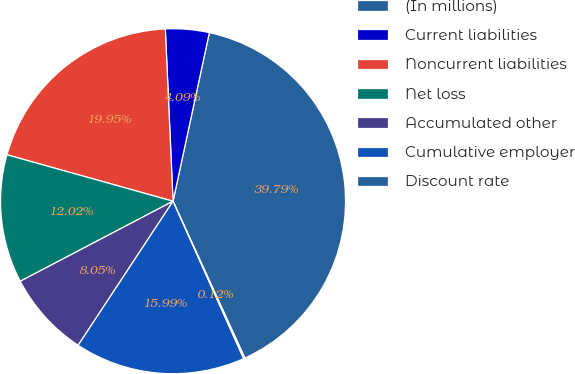Convert chart to OTSL. <chart><loc_0><loc_0><loc_500><loc_500><pie_chart><fcel>(In millions)<fcel>Current liabilities<fcel>Noncurrent liabilities<fcel>Net loss<fcel>Accumulated other<fcel>Cumulative employer<fcel>Discount rate<nl><fcel>39.79%<fcel>4.09%<fcel>19.95%<fcel>12.02%<fcel>8.05%<fcel>15.99%<fcel>0.12%<nl></chart> 